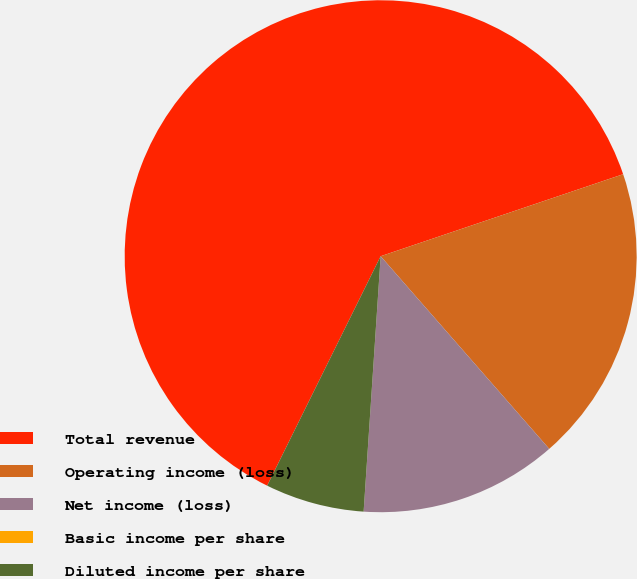Convert chart. <chart><loc_0><loc_0><loc_500><loc_500><pie_chart><fcel>Total revenue<fcel>Operating income (loss)<fcel>Net income (loss)<fcel>Basic income per share<fcel>Diluted income per share<nl><fcel>62.5%<fcel>18.75%<fcel>12.5%<fcel>0.0%<fcel>6.25%<nl></chart> 